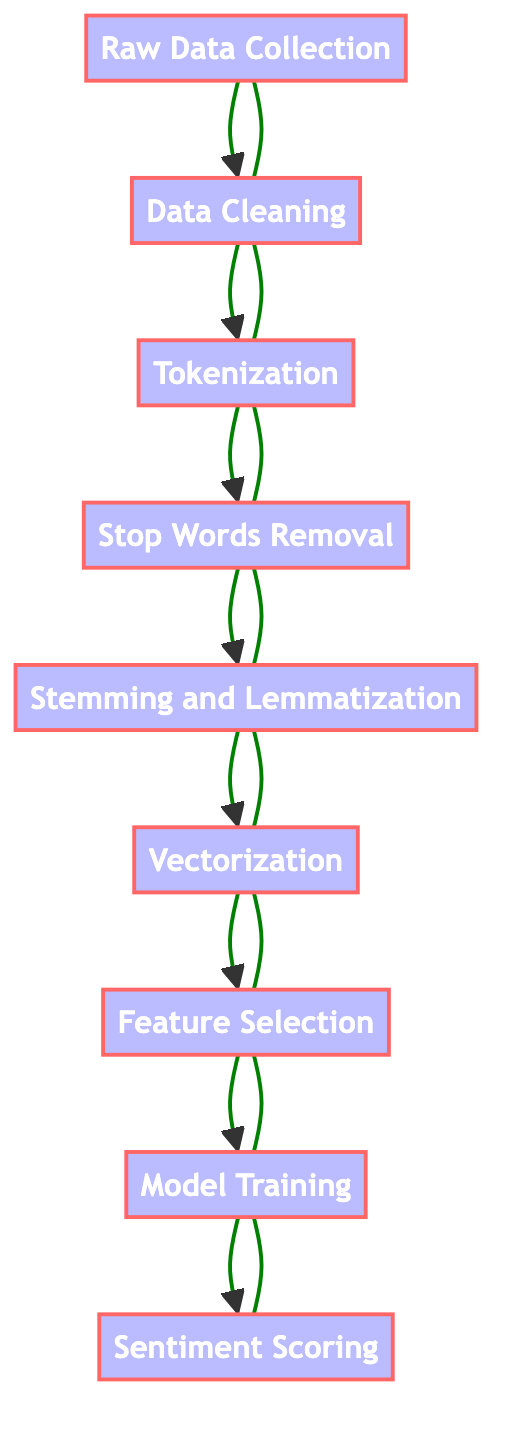What is the first step in the flow chart? The flow chart begins with "Raw Data Collection," which is the initial step in processing data for sentiment analysis.
Answer: Raw Data Collection How many total steps are represented in the flow chart? By counting the nodes highlighted in the flow chart, there are nine distinct steps from data collection to sentiment scoring.
Answer: Nine Which step comes after "Tokenization"? Following "Tokenization," the next step is "Stop Words Removal," indicating the process continues to refine the text data.
Answer: Stop Words Removal What is the last step in the process? The final action listed in the flow chart is "Sentiment Scoring," where the model assigns sentiment values to the data.
Answer: Sentiment Scoring Which step processes the text into numerical vectors? The "Vectorization" step is responsible for transforming the cleaned and tokenized text into numerical vectors for analysis.
Answer: Vectorization Which two steps are directly linked to feature relevance? The steps "Feature Selection" and "Model Training" are closely tied, as feature selection informs the training of the sentiment analysis model.
Answer: Feature Selection, Model Training What is the relationship between "Data Cleaning" and "Tokenization"? "Data Cleaning" precedes "Tokenization," indicating that the data should be cleaned before it can be effectively tokenized into individual words.
Answer: Data Cleaning → Tokenization Which steps involve language simplification techniques? The steps "Stop Words Removal" and "Stemming and Lemmatization" both focus on simplifying the text by removing unnecessary words and reducing words to their base form.
Answer: Stop Words Removal, Stemming and Lemmatization What is the purpose of the "Model Training" step? "Model Training" is aimed at educating the sentiment analysis model using the preprocessed text data so that it can learn to categorize sentiments effectively.
Answer: Train a sentiment analysis model 